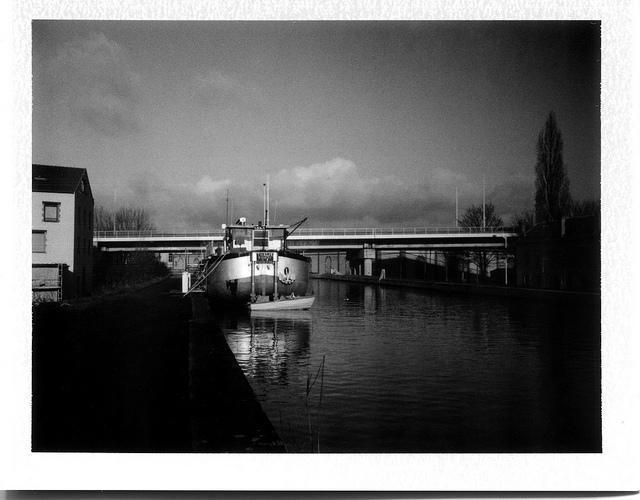How many people in the photo?
Give a very brief answer. 0. 